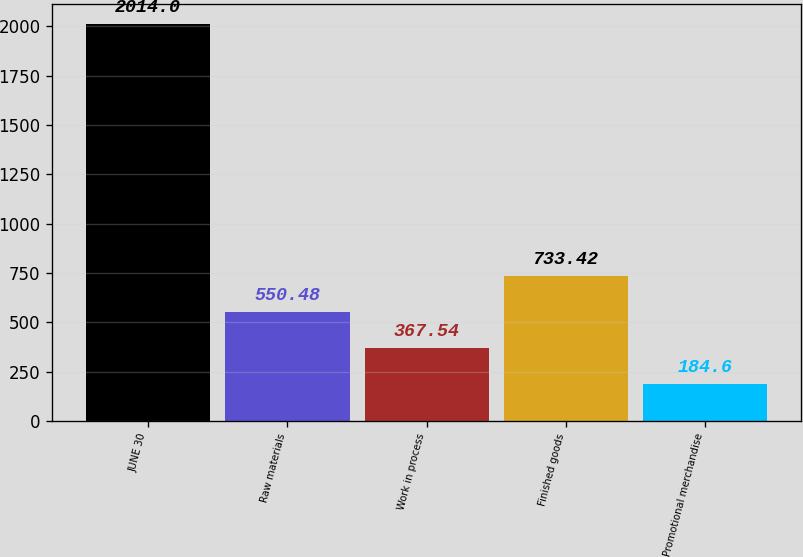<chart> <loc_0><loc_0><loc_500><loc_500><bar_chart><fcel>JUNE 30<fcel>Raw materials<fcel>Work in process<fcel>Finished goods<fcel>Promotional merchandise<nl><fcel>2014<fcel>550.48<fcel>367.54<fcel>733.42<fcel>184.6<nl></chart> 